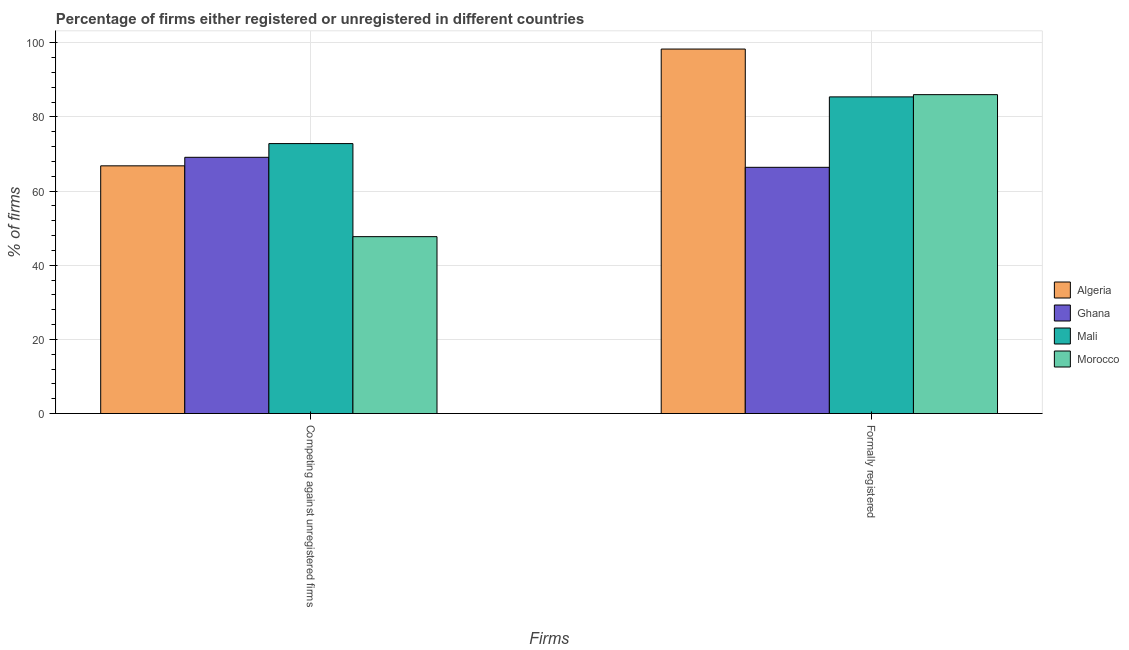How many different coloured bars are there?
Offer a terse response. 4. How many groups of bars are there?
Your answer should be very brief. 2. How many bars are there on the 1st tick from the left?
Your response must be concise. 4. What is the label of the 1st group of bars from the left?
Offer a terse response. Competing against unregistered firms. What is the percentage of formally registered firms in Ghana?
Offer a terse response. 66.4. Across all countries, what is the maximum percentage of formally registered firms?
Make the answer very short. 98.3. Across all countries, what is the minimum percentage of formally registered firms?
Ensure brevity in your answer.  66.4. In which country was the percentage of registered firms maximum?
Your answer should be compact. Mali. What is the total percentage of registered firms in the graph?
Ensure brevity in your answer.  256.4. What is the difference between the percentage of registered firms in Algeria and that in Ghana?
Your answer should be very brief. -2.3. What is the difference between the percentage of registered firms in Algeria and the percentage of formally registered firms in Morocco?
Provide a short and direct response. -19.2. What is the average percentage of formally registered firms per country?
Your answer should be compact. 84.03. What is the difference between the percentage of formally registered firms and percentage of registered firms in Ghana?
Provide a short and direct response. -2.7. What is the ratio of the percentage of registered firms in Ghana to that in Algeria?
Offer a very short reply. 1.03. Is the percentage of registered firms in Algeria less than that in Ghana?
Your answer should be compact. Yes. What does the 4th bar from the left in Formally registered represents?
Your answer should be very brief. Morocco. What does the 4th bar from the right in Formally registered represents?
Offer a terse response. Algeria. How many bars are there?
Offer a very short reply. 8. Are all the bars in the graph horizontal?
Provide a succinct answer. No. How many countries are there in the graph?
Offer a terse response. 4. Are the values on the major ticks of Y-axis written in scientific E-notation?
Your answer should be compact. No. Does the graph contain grids?
Ensure brevity in your answer.  Yes. What is the title of the graph?
Your answer should be very brief. Percentage of firms either registered or unregistered in different countries. Does "Tonga" appear as one of the legend labels in the graph?
Offer a terse response. No. What is the label or title of the X-axis?
Offer a terse response. Firms. What is the label or title of the Y-axis?
Offer a terse response. % of firms. What is the % of firms of Algeria in Competing against unregistered firms?
Offer a very short reply. 66.8. What is the % of firms in Ghana in Competing against unregistered firms?
Your answer should be compact. 69.1. What is the % of firms in Mali in Competing against unregistered firms?
Ensure brevity in your answer.  72.8. What is the % of firms of Morocco in Competing against unregistered firms?
Your answer should be very brief. 47.7. What is the % of firms in Algeria in Formally registered?
Provide a succinct answer. 98.3. What is the % of firms of Ghana in Formally registered?
Your answer should be very brief. 66.4. What is the % of firms in Mali in Formally registered?
Keep it short and to the point. 85.4. Across all Firms, what is the maximum % of firms of Algeria?
Your answer should be very brief. 98.3. Across all Firms, what is the maximum % of firms in Ghana?
Provide a short and direct response. 69.1. Across all Firms, what is the maximum % of firms in Mali?
Give a very brief answer. 85.4. Across all Firms, what is the maximum % of firms of Morocco?
Your answer should be compact. 86. Across all Firms, what is the minimum % of firms in Algeria?
Make the answer very short. 66.8. Across all Firms, what is the minimum % of firms in Ghana?
Provide a short and direct response. 66.4. Across all Firms, what is the minimum % of firms in Mali?
Give a very brief answer. 72.8. Across all Firms, what is the minimum % of firms in Morocco?
Your answer should be compact. 47.7. What is the total % of firms of Algeria in the graph?
Make the answer very short. 165.1. What is the total % of firms of Ghana in the graph?
Provide a short and direct response. 135.5. What is the total % of firms in Mali in the graph?
Ensure brevity in your answer.  158.2. What is the total % of firms in Morocco in the graph?
Provide a short and direct response. 133.7. What is the difference between the % of firms of Algeria in Competing against unregistered firms and that in Formally registered?
Provide a succinct answer. -31.5. What is the difference between the % of firms of Ghana in Competing against unregistered firms and that in Formally registered?
Keep it short and to the point. 2.7. What is the difference between the % of firms in Mali in Competing against unregistered firms and that in Formally registered?
Give a very brief answer. -12.6. What is the difference between the % of firms of Morocco in Competing against unregistered firms and that in Formally registered?
Provide a short and direct response. -38.3. What is the difference between the % of firms of Algeria in Competing against unregistered firms and the % of firms of Ghana in Formally registered?
Offer a terse response. 0.4. What is the difference between the % of firms of Algeria in Competing against unregistered firms and the % of firms of Mali in Formally registered?
Ensure brevity in your answer.  -18.6. What is the difference between the % of firms of Algeria in Competing against unregistered firms and the % of firms of Morocco in Formally registered?
Offer a very short reply. -19.2. What is the difference between the % of firms in Ghana in Competing against unregistered firms and the % of firms in Mali in Formally registered?
Give a very brief answer. -16.3. What is the difference between the % of firms of Ghana in Competing against unregistered firms and the % of firms of Morocco in Formally registered?
Provide a succinct answer. -16.9. What is the average % of firms of Algeria per Firms?
Your answer should be compact. 82.55. What is the average % of firms in Ghana per Firms?
Ensure brevity in your answer.  67.75. What is the average % of firms in Mali per Firms?
Keep it short and to the point. 79.1. What is the average % of firms in Morocco per Firms?
Provide a short and direct response. 66.85. What is the difference between the % of firms in Algeria and % of firms in Ghana in Competing against unregistered firms?
Ensure brevity in your answer.  -2.3. What is the difference between the % of firms of Algeria and % of firms of Mali in Competing against unregistered firms?
Ensure brevity in your answer.  -6. What is the difference between the % of firms in Ghana and % of firms in Mali in Competing against unregistered firms?
Provide a short and direct response. -3.7. What is the difference between the % of firms of Ghana and % of firms of Morocco in Competing against unregistered firms?
Provide a short and direct response. 21.4. What is the difference between the % of firms in Mali and % of firms in Morocco in Competing against unregistered firms?
Your response must be concise. 25.1. What is the difference between the % of firms in Algeria and % of firms in Ghana in Formally registered?
Ensure brevity in your answer.  31.9. What is the difference between the % of firms in Ghana and % of firms in Morocco in Formally registered?
Your answer should be very brief. -19.6. What is the difference between the % of firms of Mali and % of firms of Morocco in Formally registered?
Give a very brief answer. -0.6. What is the ratio of the % of firms of Algeria in Competing against unregistered firms to that in Formally registered?
Your answer should be compact. 0.68. What is the ratio of the % of firms in Ghana in Competing against unregistered firms to that in Formally registered?
Keep it short and to the point. 1.04. What is the ratio of the % of firms in Mali in Competing against unregistered firms to that in Formally registered?
Provide a short and direct response. 0.85. What is the ratio of the % of firms in Morocco in Competing against unregistered firms to that in Formally registered?
Your answer should be very brief. 0.55. What is the difference between the highest and the second highest % of firms in Algeria?
Ensure brevity in your answer.  31.5. What is the difference between the highest and the second highest % of firms of Ghana?
Provide a succinct answer. 2.7. What is the difference between the highest and the second highest % of firms in Morocco?
Your response must be concise. 38.3. What is the difference between the highest and the lowest % of firms in Algeria?
Your answer should be very brief. 31.5. What is the difference between the highest and the lowest % of firms in Mali?
Your answer should be very brief. 12.6. What is the difference between the highest and the lowest % of firms in Morocco?
Keep it short and to the point. 38.3. 